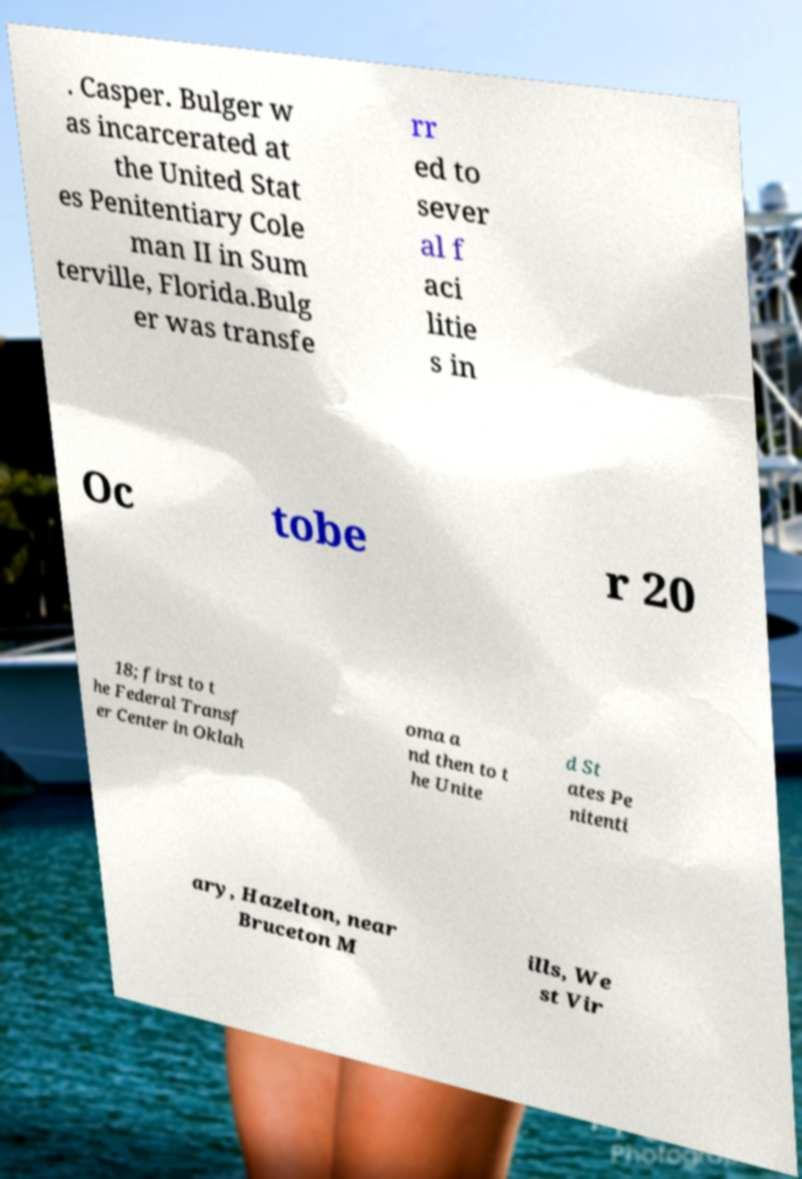For documentation purposes, I need the text within this image transcribed. Could you provide that? . Casper. Bulger w as incarcerated at the United Stat es Penitentiary Cole man II in Sum terville, Florida.Bulg er was transfe rr ed to sever al f aci litie s in Oc tobe r 20 18; first to t he Federal Transf er Center in Oklah oma a nd then to t he Unite d St ates Pe nitenti ary, Hazelton, near Bruceton M ills, We st Vir 